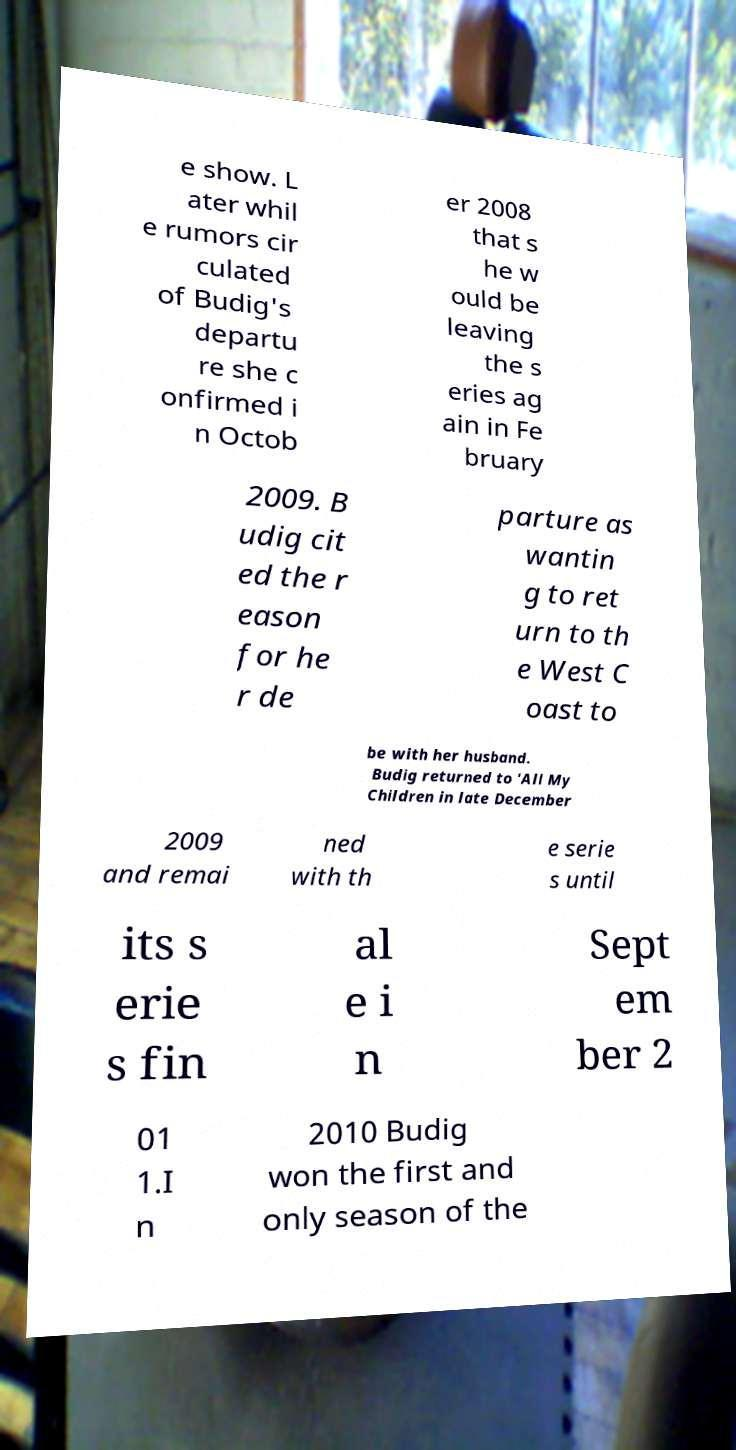For documentation purposes, I need the text within this image transcribed. Could you provide that? e show. L ater whil e rumors cir culated of Budig's departu re she c onfirmed i n Octob er 2008 that s he w ould be leaving the s eries ag ain in Fe bruary 2009. B udig cit ed the r eason for he r de parture as wantin g to ret urn to th e West C oast to be with her husband. Budig returned to 'All My Children in late December 2009 and remai ned with th e serie s until its s erie s fin al e i n Sept em ber 2 01 1.I n 2010 Budig won the first and only season of the 